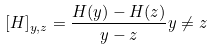<formula> <loc_0><loc_0><loc_500><loc_500>[ H ] _ { y , z } = \frac { H ( y ) - H ( z ) } { y - z } y \ne z</formula> 